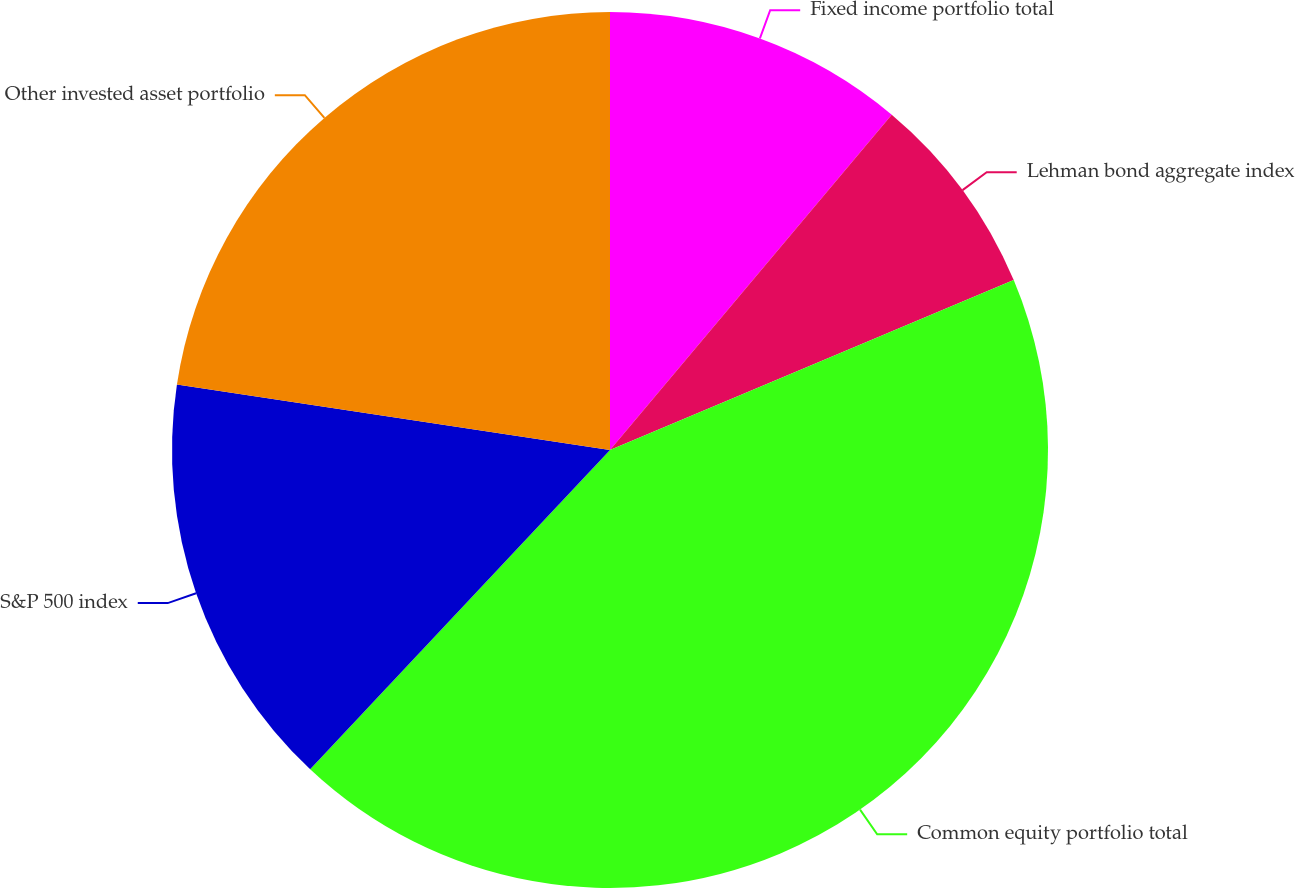Convert chart to OTSL. <chart><loc_0><loc_0><loc_500><loc_500><pie_chart><fcel>Fixed income portfolio total<fcel>Lehman bond aggregate index<fcel>Common equity portfolio total<fcel>S&P 500 index<fcel>Other invested asset portfolio<nl><fcel>11.12%<fcel>7.54%<fcel>43.34%<fcel>15.39%<fcel>22.61%<nl></chart> 